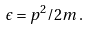Convert formula to latex. <formula><loc_0><loc_0><loc_500><loc_500>\epsilon = p ^ { 2 } / 2 m \, .</formula> 